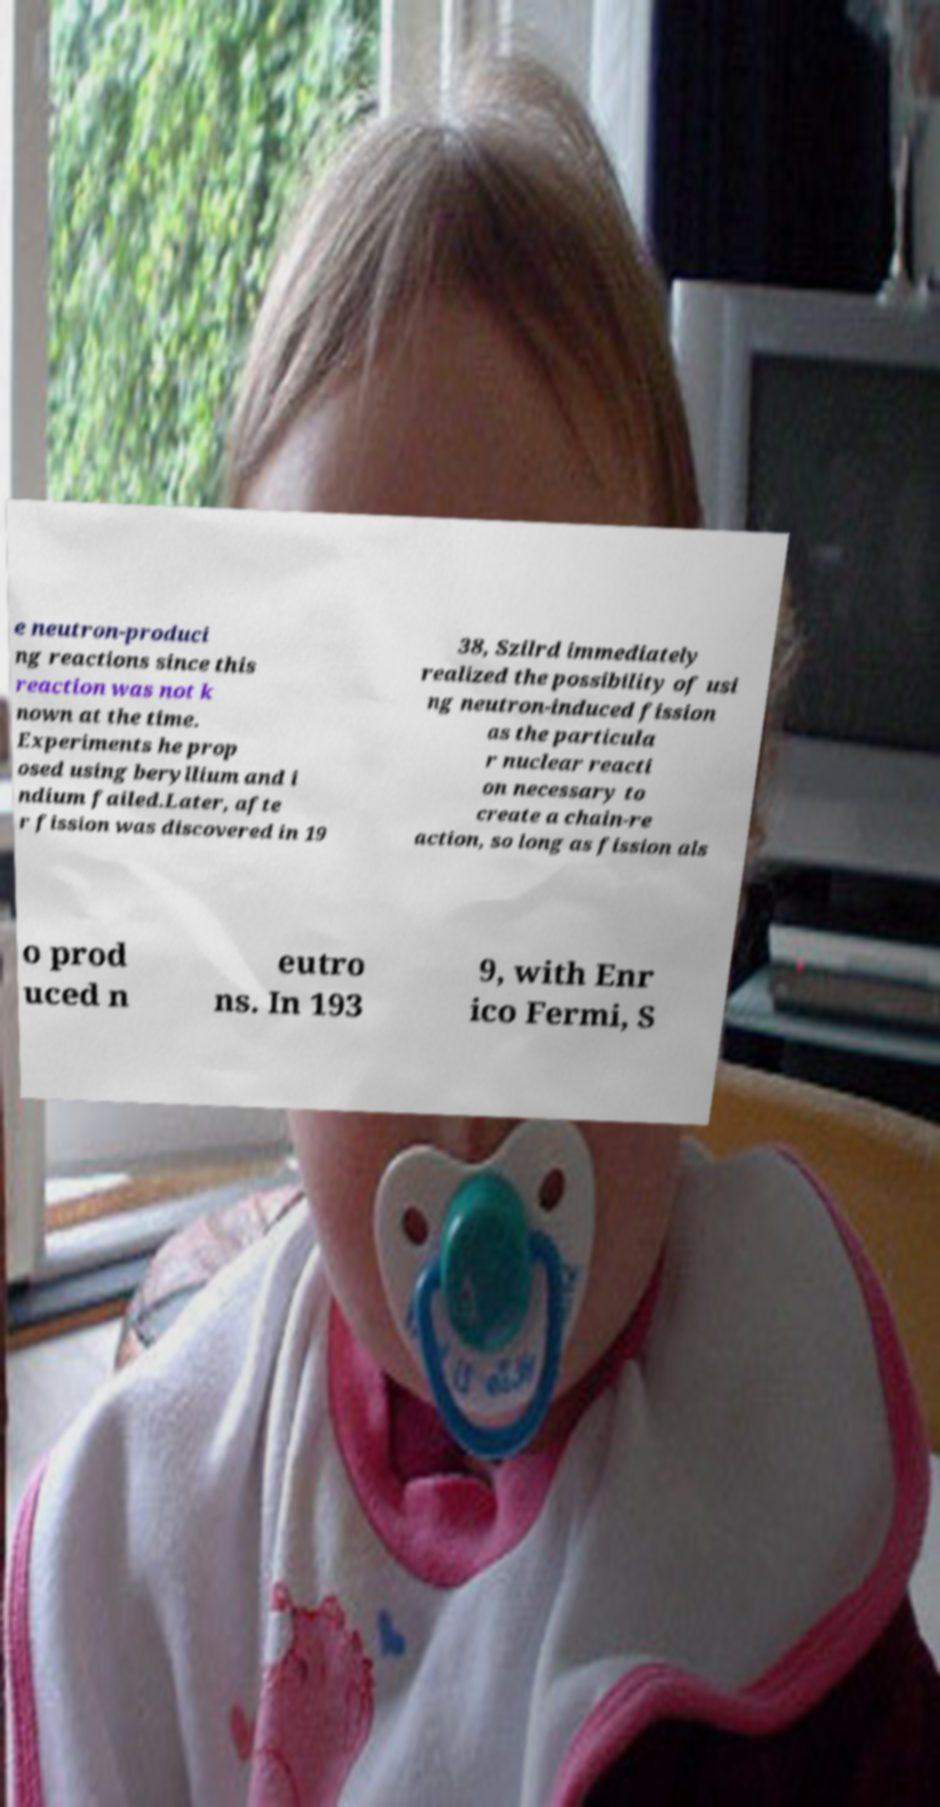Could you assist in decoding the text presented in this image and type it out clearly? e neutron-produci ng reactions since this reaction was not k nown at the time. Experiments he prop osed using beryllium and i ndium failed.Later, afte r fission was discovered in 19 38, Szilrd immediately realized the possibility of usi ng neutron-induced fission as the particula r nuclear reacti on necessary to create a chain-re action, so long as fission als o prod uced n eutro ns. In 193 9, with Enr ico Fermi, S 